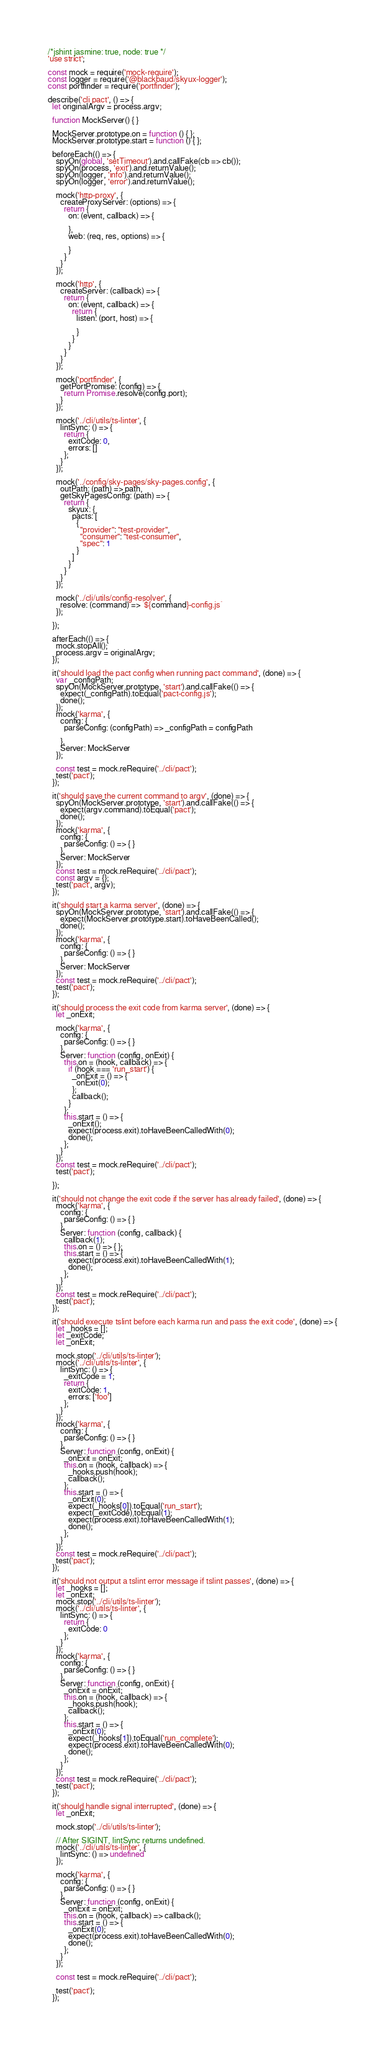<code> <loc_0><loc_0><loc_500><loc_500><_JavaScript_>/*jshint jasmine: true, node: true */
'use strict';

const mock = require('mock-require');
const logger = require('@blackbaud/skyux-logger');
const portfinder = require('portfinder');

describe('cli pact', () => {
  let originalArgv = process.argv;

  function MockServer() { }

  MockServer.prototype.on = function () { };
  MockServer.prototype.start = function () { };

  beforeEach(() => {
    spyOn(global, 'setTimeout').and.callFake(cb => cb());
    spyOn(process, 'exit').and.returnValue();
    spyOn(logger, 'info').and.returnValue();
    spyOn(logger, 'error').and.returnValue();

    mock('http-proxy', {
      createProxyServer: (options) => {
        return {
          on: (event, callback) => {

          },
          web: (req, res, options) => {

          }
        }
      }
    });

    mock('http', {
      createServer: (callback) => {
        return {
          on: (event, callback) => {
            return {
              listen: (port, host) => {

              }
            }
          }
        }
      }
    });

    mock('portfinder', {
      getPortPromise: (config) => {
        return Promise.resolve(config.port);
      }
    });

    mock('../cli/utils/ts-linter', {
      lintSync: () => {
        return {
          exitCode: 0,
          errors: []
        };
      }
    });

    mock('../config/sky-pages/sky-pages.config', {
      outPath: (path) => path,
      getSkyPagesConfig: (path) => {
        return {
          skyux: {
            pacts: [
              {
                "provider": "test-provider",
                "consumer": "test-consumer",
                "spec": 1
              }
            ]
          }
        }
      }
    });

    mock('../cli/utils/config-resolver', {
      resolve: (command) => `${command}-config.js`
    });

  });

  afterEach(() => {
    mock.stopAll();
    process.argv = originalArgv;
  });

  it('should load the pact config when running pact command', (done) => {
    var _configPath;
    spyOn(MockServer.prototype, 'start').and.callFake(() => {
      expect(_configPath).toEqual('pact-config.js');
      done();
    });
    mock('karma', {
      config: {
        parseConfig: (configPath) => _configPath = configPath

      },
      Server: MockServer
    });

    const test = mock.reRequire('../cli/pact');
    test('pact');
  });

  it('should save the current command to argv', (done) => {
    spyOn(MockServer.prototype, 'start').and.callFake(() => {
      expect(argv.command).toEqual('pact');
      done();
    });
    mock('karma', {
      config: {
        parseConfig: () => { }
      },
      Server: MockServer
    });
    const test = mock.reRequire('../cli/pact');
    const argv = {};
    test('pact', argv);
  });

  it('should start a karma server', (done) => {
    spyOn(MockServer.prototype, 'start').and.callFake(() => {
      expect(MockServer.prototype.start).toHaveBeenCalled();
      done();
    });
    mock('karma', {
      config: {
        parseConfig: () => { }
      },
      Server: MockServer
    });
    const test = mock.reRequire('../cli/pact');
    test('pact');
  });

  it('should process the exit code from karma server', (done) => {
    let _onExit;

    mock('karma', {
      config: {
        parseConfig: () => { }
      },
      Server: function (config, onExit) {
        this.on = (hook, callback) => {
          if (hook === 'run_start') {
            _onExit = () => {
              onExit(0);
            };
            callback();
          }
        };
        this.start = () => {
          _onExit();
          expect(process.exit).toHaveBeenCalledWith(0);
          done();
        };
      }
    });
    const test = mock.reRequire('../cli/pact');
    test('pact');

  });

  it('should not change the exit code if the server has already failed', (done) => {
    mock('karma', {
      config: {
        parseConfig: () => { }
      },
      Server: function (config, callback) {
        callback(1);
        this.on = () => { };
        this.start = () => {
          expect(process.exit).toHaveBeenCalledWith(1);
          done();
        };
      }
    });
    const test = mock.reRequire('../cli/pact');
    test('pact');
  });

  it('should execute tslint before each karma run and pass the exit code', (done) => {
    let _hooks = [];
    let _exitCode;
    let _onExit;

    mock.stop('../cli/utils/ts-linter');
    mock('../cli/utils/ts-linter', {
      lintSync: () => {
        _exitCode = 1;
        return {
          exitCode: 1,
          errors: ['foo']
        };
      }
    });
    mock('karma', {
      config: {
        parseConfig: () => { }
      },
      Server: function (config, onExit) {
        _onExit = onExit;
        this.on = (hook, callback) => {
          _hooks.push(hook);
          callback();
        };
        this.start = () => {
          _onExit(0);
          expect(_hooks[0]).toEqual('run_start');
          expect(_exitCode).toEqual(1);
          expect(process.exit).toHaveBeenCalledWith(1);
          done();
        };
      }
    });
    const test = mock.reRequire('../cli/pact');
    test('pact');
  });

  it('should not output a tslint error message if tslint passes', (done) => {
    let _hooks = [];
    let _onExit;
    mock.stop('../cli/utils/ts-linter');
    mock('../cli/utils/ts-linter', {
      lintSync: () => {
        return {
          exitCode: 0
        };
      }
    });
    mock('karma', {
      config: {
        parseConfig: () => { }
      },
      Server: function (config, onExit) {
        _onExit = onExit;
        this.on = (hook, callback) => {
          _hooks.push(hook);
          callback();
        };
        this.start = () => {
          _onExit(0);
          expect(_hooks[1]).toEqual('run_complete');
          expect(process.exit).toHaveBeenCalledWith(0);
          done();
        };
      }
    });
    const test = mock.reRequire('../cli/pact');
    test('pact');
  });

  it('should handle signal interrupted', (done) => {
    let _onExit;

    mock.stop('../cli/utils/ts-linter');

    // After SIGINT, lintSync returns undefined.
    mock('../cli/utils/ts-linter', {
      lintSync: () => undefined
    });

    mock('karma', {
      config: {
        parseConfig: () => { }
      },
      Server: function (config, onExit) {
        _onExit = onExit;
        this.on = (hook, callback) => callback();
        this.start = () => {
          _onExit(0);
          expect(process.exit).toHaveBeenCalledWith(0);
          done();
        };
      }
    });

    const test = mock.reRequire('../cli/pact');

    test('pact');
  });
</code> 